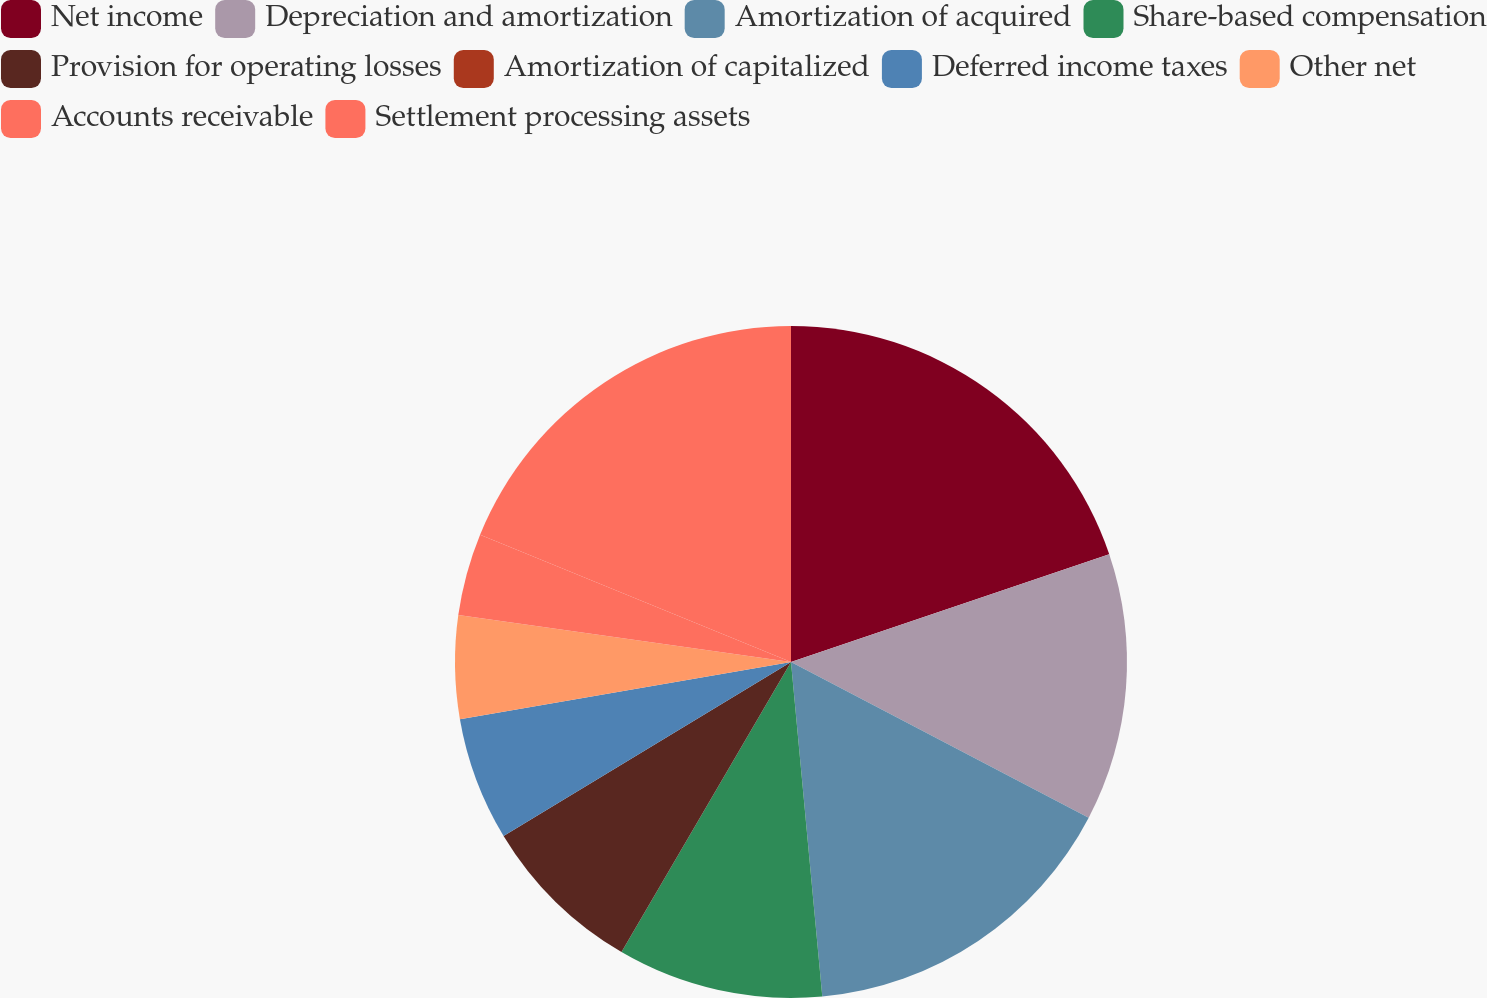Convert chart to OTSL. <chart><loc_0><loc_0><loc_500><loc_500><pie_chart><fcel>Net income<fcel>Depreciation and amortization<fcel>Amortization of acquired<fcel>Share-based compensation<fcel>Provision for operating losses<fcel>Amortization of capitalized<fcel>Deferred income taxes<fcel>Other net<fcel>Accounts receivable<fcel>Settlement processing assets<nl><fcel>19.8%<fcel>12.87%<fcel>15.84%<fcel>9.9%<fcel>7.92%<fcel>0.0%<fcel>5.94%<fcel>4.95%<fcel>3.96%<fcel>18.81%<nl></chart> 